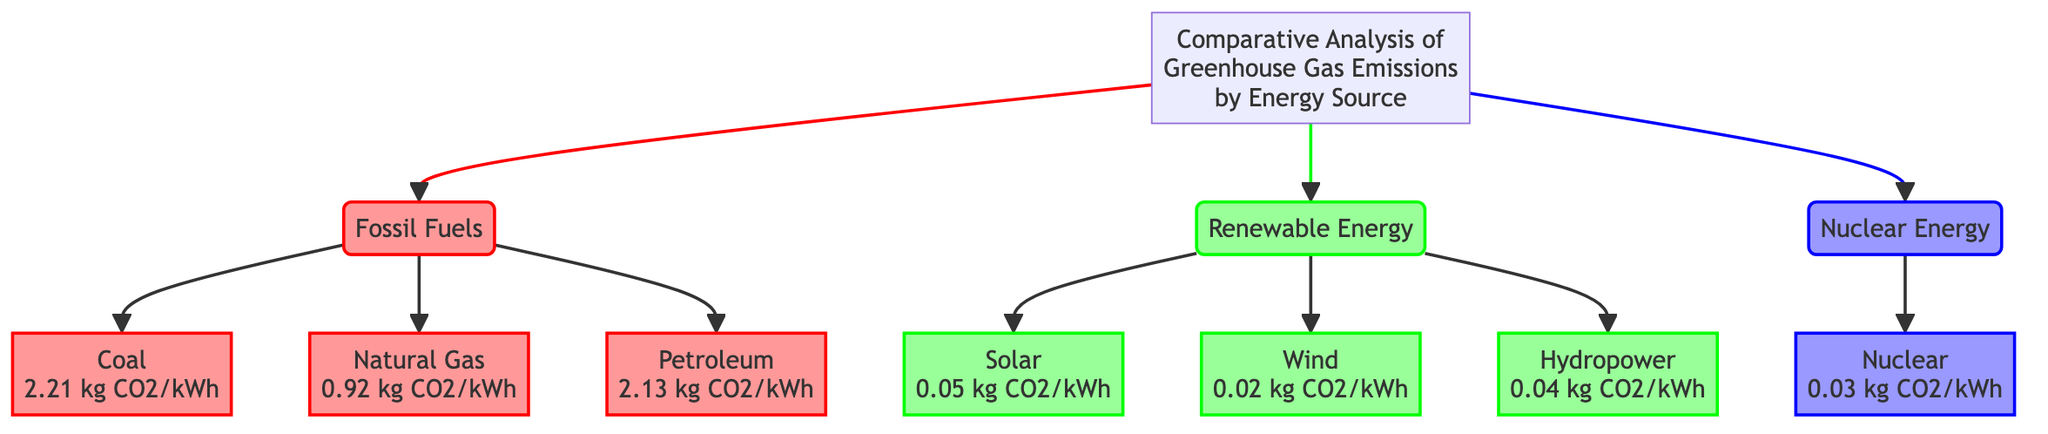What is the CO2 emission for coal? The diagram explicitly states that coal has a CO2 emission of 2.21 kg CO2/kWh, as indicated by the label connected to the "Coal" node in the fossil fuel section.
Answer: 2.21 kg CO2/kWh How many energy sources are listed under renewable energy? By inspecting the renewable energy section of the diagram, we can count three distinct sources: Solar, Wind, and Hydropower. This shows that there are three energy sources categorized as renewable.
Answer: 3 Which energy source has the lowest CO2 emissions? Analyzing the data presented in the diagram, Wind is shown to have the lowest CO2 emissions at 0.02 kg CO2/kWh, which is the smallest number when compared to other sources listed.
Answer: Wind What is the total number of energy types represented in the diagram? The diagram presents three main categories of energy: Fossil Fuels, Renewable Energy, and Nuclear Energy. Each category contains its respective sources, thus totaling three distinct types of energy.
Answer: 3 Which energy source contributes more CO2 emissions, Natural Gas or Hydropower? By comparing the CO2 emissions indicated in the diagram, Natural Gas has an emission of 0.92 kg CO2/kWh, while Hydropower has a significantly lower emission of 0.04 kg CO2/kWh. Therefore, we conclude that Natural Gas contributes more emissions than Hydropower.
Answer: Natural Gas What color represents renewable energy in the diagram? The diagram uses a specific color scheme to differentiate between energy types. Renewable energy sources are represented using a green color fill (#99FF99), which is clearly labeled in the class definition section of the code.
Answer: Green How many kg CO2/kWh does Nuclear Energy produce? The diagram states that Nuclear energy produces 0.03 kg CO2/kWh near the "Nuclear" node, which specifically identifies its carbon emissions.
Answer: 0.03 kg CO2/kWh What is the highest CO2 emission recorded in the fossil fuel section? By examining the fossil fuel section, we see that Coal has the highest emissions recorded at 2.21 kg CO2/kWh compared to Natural Gas, which emits 0.92 kg CO2/kWh, and Petroleum at 2.13 kg CO2/kWh. This shows that Coal is the highest emitter among fossil fuels.
Answer: Coal 